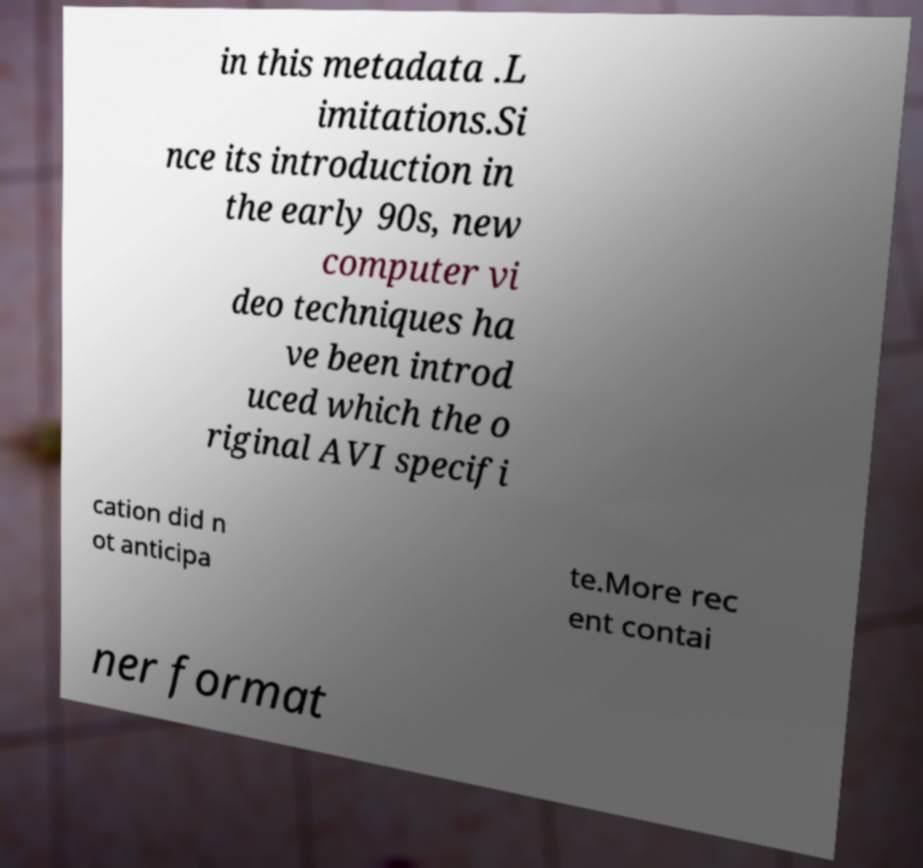Can you read and provide the text displayed in the image?This photo seems to have some interesting text. Can you extract and type it out for me? in this metadata .L imitations.Si nce its introduction in the early 90s, new computer vi deo techniques ha ve been introd uced which the o riginal AVI specifi cation did n ot anticipa te.More rec ent contai ner format 